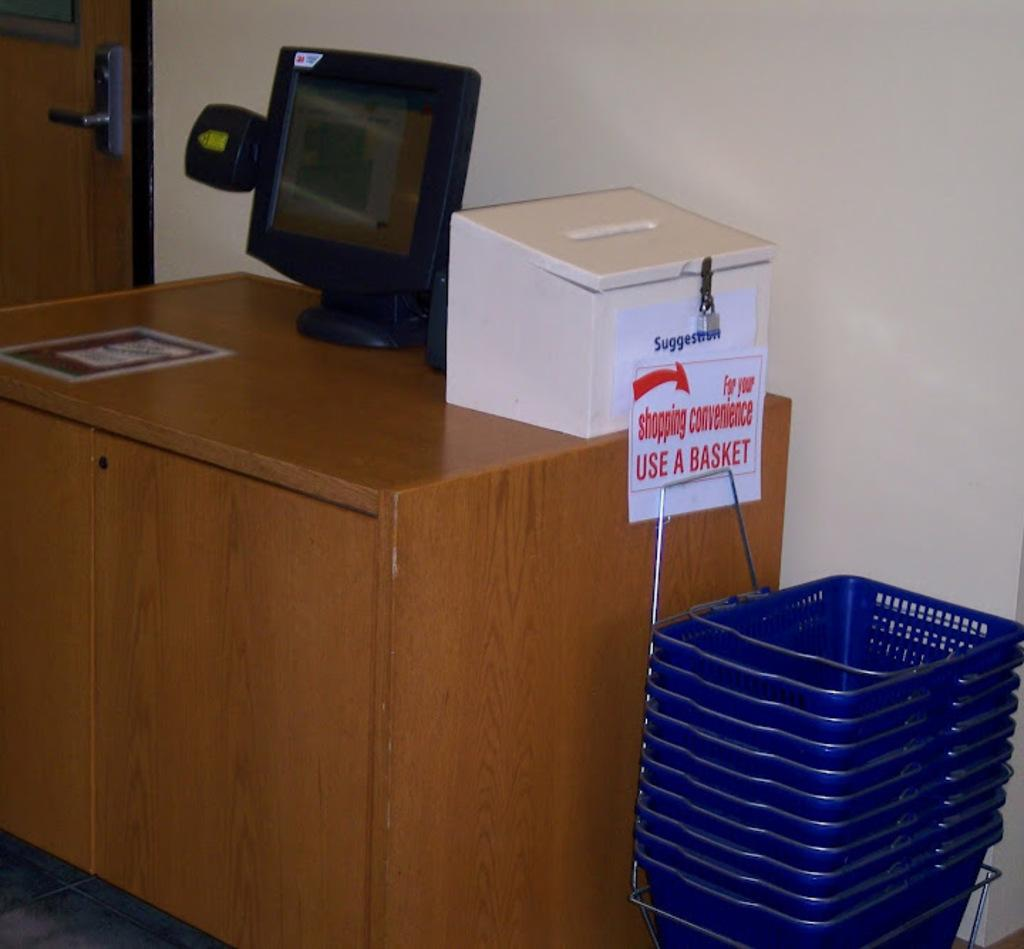What is the main piece of furniture in the image? There is a table in the image. What electronic device is on the table? There is a monitor on the table. What other objects are on the table? There is a box and baskets on the table. What can be seen in the background of the image? There is a wall and a door in the background of the image. How many friends are sitting on the cactus in the image? There is no cactus or friends present in the image. 